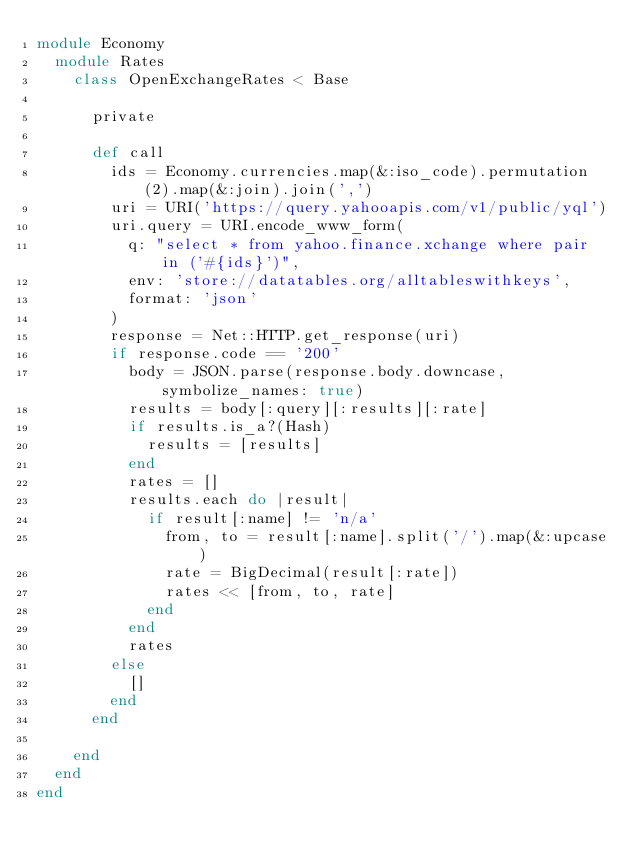<code> <loc_0><loc_0><loc_500><loc_500><_Ruby_>module Economy
  module Rates
    class OpenExchangeRates < Base

      private

      def call
        ids = Economy.currencies.map(&:iso_code).permutation(2).map(&:join).join(',')
        uri = URI('https://query.yahooapis.com/v1/public/yql')
        uri.query = URI.encode_www_form(
          q: "select * from yahoo.finance.xchange where pair in ('#{ids}')",
          env: 'store://datatables.org/alltableswithkeys',
          format: 'json'
        )
        response = Net::HTTP.get_response(uri)
        if response.code == '200'
          body = JSON.parse(response.body.downcase, symbolize_names: true)
          results = body[:query][:results][:rate]
          if results.is_a?(Hash)
            results = [results]
          end
          rates = []
          results.each do |result|
            if result[:name] != 'n/a'
              from, to = result[:name].split('/').map(&:upcase)
              rate = BigDecimal(result[:rate])
              rates << [from, to, rate]
            end
          end
          rates
        else
          []
        end
      end

    end
  end
end
</code> 